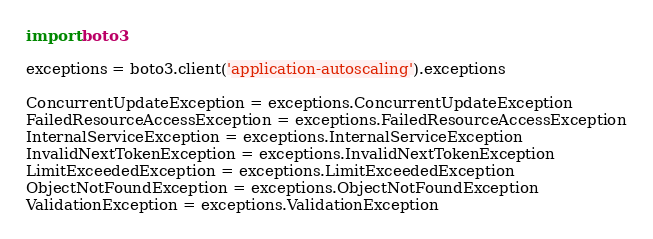Convert code to text. <code><loc_0><loc_0><loc_500><loc_500><_Python_>import boto3

exceptions = boto3.client('application-autoscaling').exceptions

ConcurrentUpdateException = exceptions.ConcurrentUpdateException
FailedResourceAccessException = exceptions.FailedResourceAccessException
InternalServiceException = exceptions.InternalServiceException
InvalidNextTokenException = exceptions.InvalidNextTokenException
LimitExceededException = exceptions.LimitExceededException
ObjectNotFoundException = exceptions.ObjectNotFoundException
ValidationException = exceptions.ValidationException
</code> 